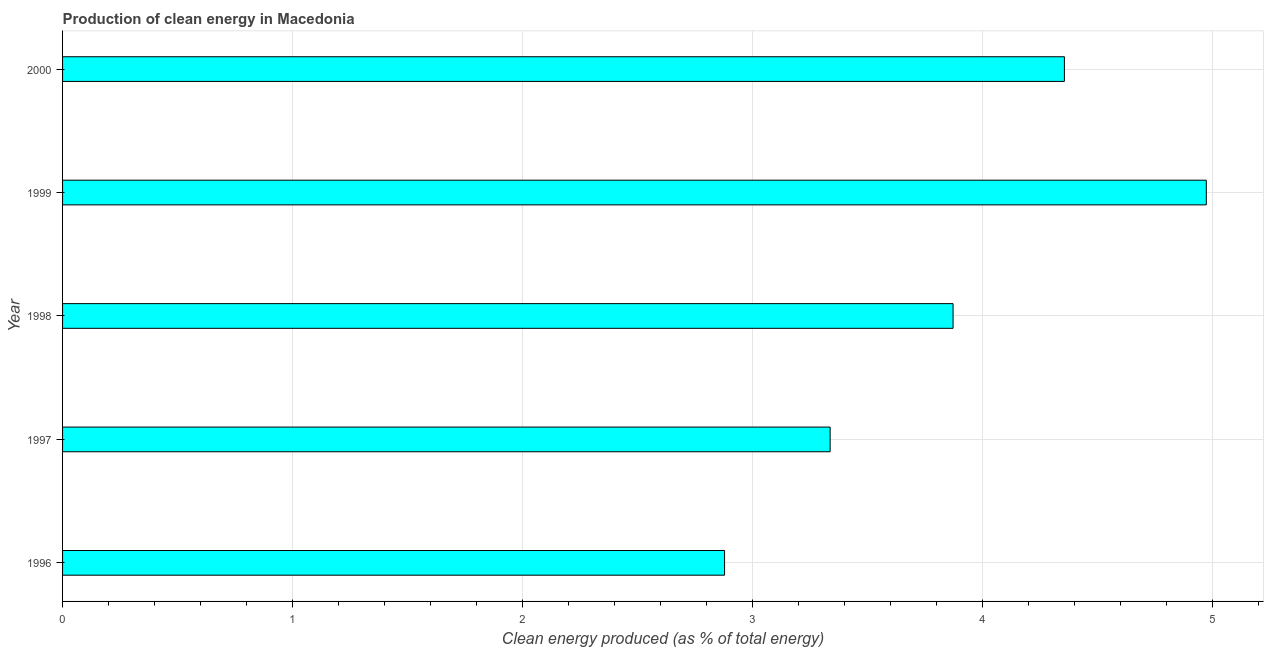Does the graph contain any zero values?
Provide a succinct answer. No. Does the graph contain grids?
Offer a very short reply. Yes. What is the title of the graph?
Provide a short and direct response. Production of clean energy in Macedonia. What is the label or title of the X-axis?
Give a very brief answer. Clean energy produced (as % of total energy). What is the production of clean energy in 1998?
Ensure brevity in your answer.  3.87. Across all years, what is the maximum production of clean energy?
Your answer should be very brief. 4.97. Across all years, what is the minimum production of clean energy?
Your answer should be compact. 2.88. In which year was the production of clean energy maximum?
Make the answer very short. 1999. In which year was the production of clean energy minimum?
Offer a very short reply. 1996. What is the sum of the production of clean energy?
Offer a terse response. 19.42. What is the difference between the production of clean energy in 1997 and 1999?
Offer a very short reply. -1.64. What is the average production of clean energy per year?
Make the answer very short. 3.88. What is the median production of clean energy?
Ensure brevity in your answer.  3.87. In how many years, is the production of clean energy greater than 4.8 %?
Give a very brief answer. 1. What is the ratio of the production of clean energy in 1998 to that in 2000?
Give a very brief answer. 0.89. What is the difference between the highest and the second highest production of clean energy?
Provide a succinct answer. 0.62. What is the difference between the highest and the lowest production of clean energy?
Your answer should be very brief. 2.09. In how many years, is the production of clean energy greater than the average production of clean energy taken over all years?
Ensure brevity in your answer.  2. How many bars are there?
Offer a very short reply. 5. How many years are there in the graph?
Provide a succinct answer. 5. Are the values on the major ticks of X-axis written in scientific E-notation?
Give a very brief answer. No. What is the Clean energy produced (as % of total energy) in 1996?
Provide a short and direct response. 2.88. What is the Clean energy produced (as % of total energy) in 1997?
Provide a succinct answer. 3.34. What is the Clean energy produced (as % of total energy) in 1998?
Your answer should be very brief. 3.87. What is the Clean energy produced (as % of total energy) in 1999?
Make the answer very short. 4.97. What is the Clean energy produced (as % of total energy) of 2000?
Provide a short and direct response. 4.36. What is the difference between the Clean energy produced (as % of total energy) in 1996 and 1997?
Keep it short and to the point. -0.46. What is the difference between the Clean energy produced (as % of total energy) in 1996 and 1998?
Make the answer very short. -0.99. What is the difference between the Clean energy produced (as % of total energy) in 1996 and 1999?
Make the answer very short. -2.09. What is the difference between the Clean energy produced (as % of total energy) in 1996 and 2000?
Your response must be concise. -1.48. What is the difference between the Clean energy produced (as % of total energy) in 1997 and 1998?
Your response must be concise. -0.53. What is the difference between the Clean energy produced (as % of total energy) in 1997 and 1999?
Your answer should be very brief. -1.64. What is the difference between the Clean energy produced (as % of total energy) in 1997 and 2000?
Give a very brief answer. -1.02. What is the difference between the Clean energy produced (as % of total energy) in 1998 and 1999?
Provide a short and direct response. -1.1. What is the difference between the Clean energy produced (as % of total energy) in 1998 and 2000?
Keep it short and to the point. -0.48. What is the difference between the Clean energy produced (as % of total energy) in 1999 and 2000?
Ensure brevity in your answer.  0.62. What is the ratio of the Clean energy produced (as % of total energy) in 1996 to that in 1997?
Make the answer very short. 0.86. What is the ratio of the Clean energy produced (as % of total energy) in 1996 to that in 1998?
Make the answer very short. 0.74. What is the ratio of the Clean energy produced (as % of total energy) in 1996 to that in 1999?
Provide a short and direct response. 0.58. What is the ratio of the Clean energy produced (as % of total energy) in 1996 to that in 2000?
Your response must be concise. 0.66. What is the ratio of the Clean energy produced (as % of total energy) in 1997 to that in 1998?
Make the answer very short. 0.86. What is the ratio of the Clean energy produced (as % of total energy) in 1997 to that in 1999?
Give a very brief answer. 0.67. What is the ratio of the Clean energy produced (as % of total energy) in 1997 to that in 2000?
Offer a very short reply. 0.77. What is the ratio of the Clean energy produced (as % of total energy) in 1998 to that in 1999?
Keep it short and to the point. 0.78. What is the ratio of the Clean energy produced (as % of total energy) in 1998 to that in 2000?
Your answer should be compact. 0.89. What is the ratio of the Clean energy produced (as % of total energy) in 1999 to that in 2000?
Your answer should be compact. 1.14. 